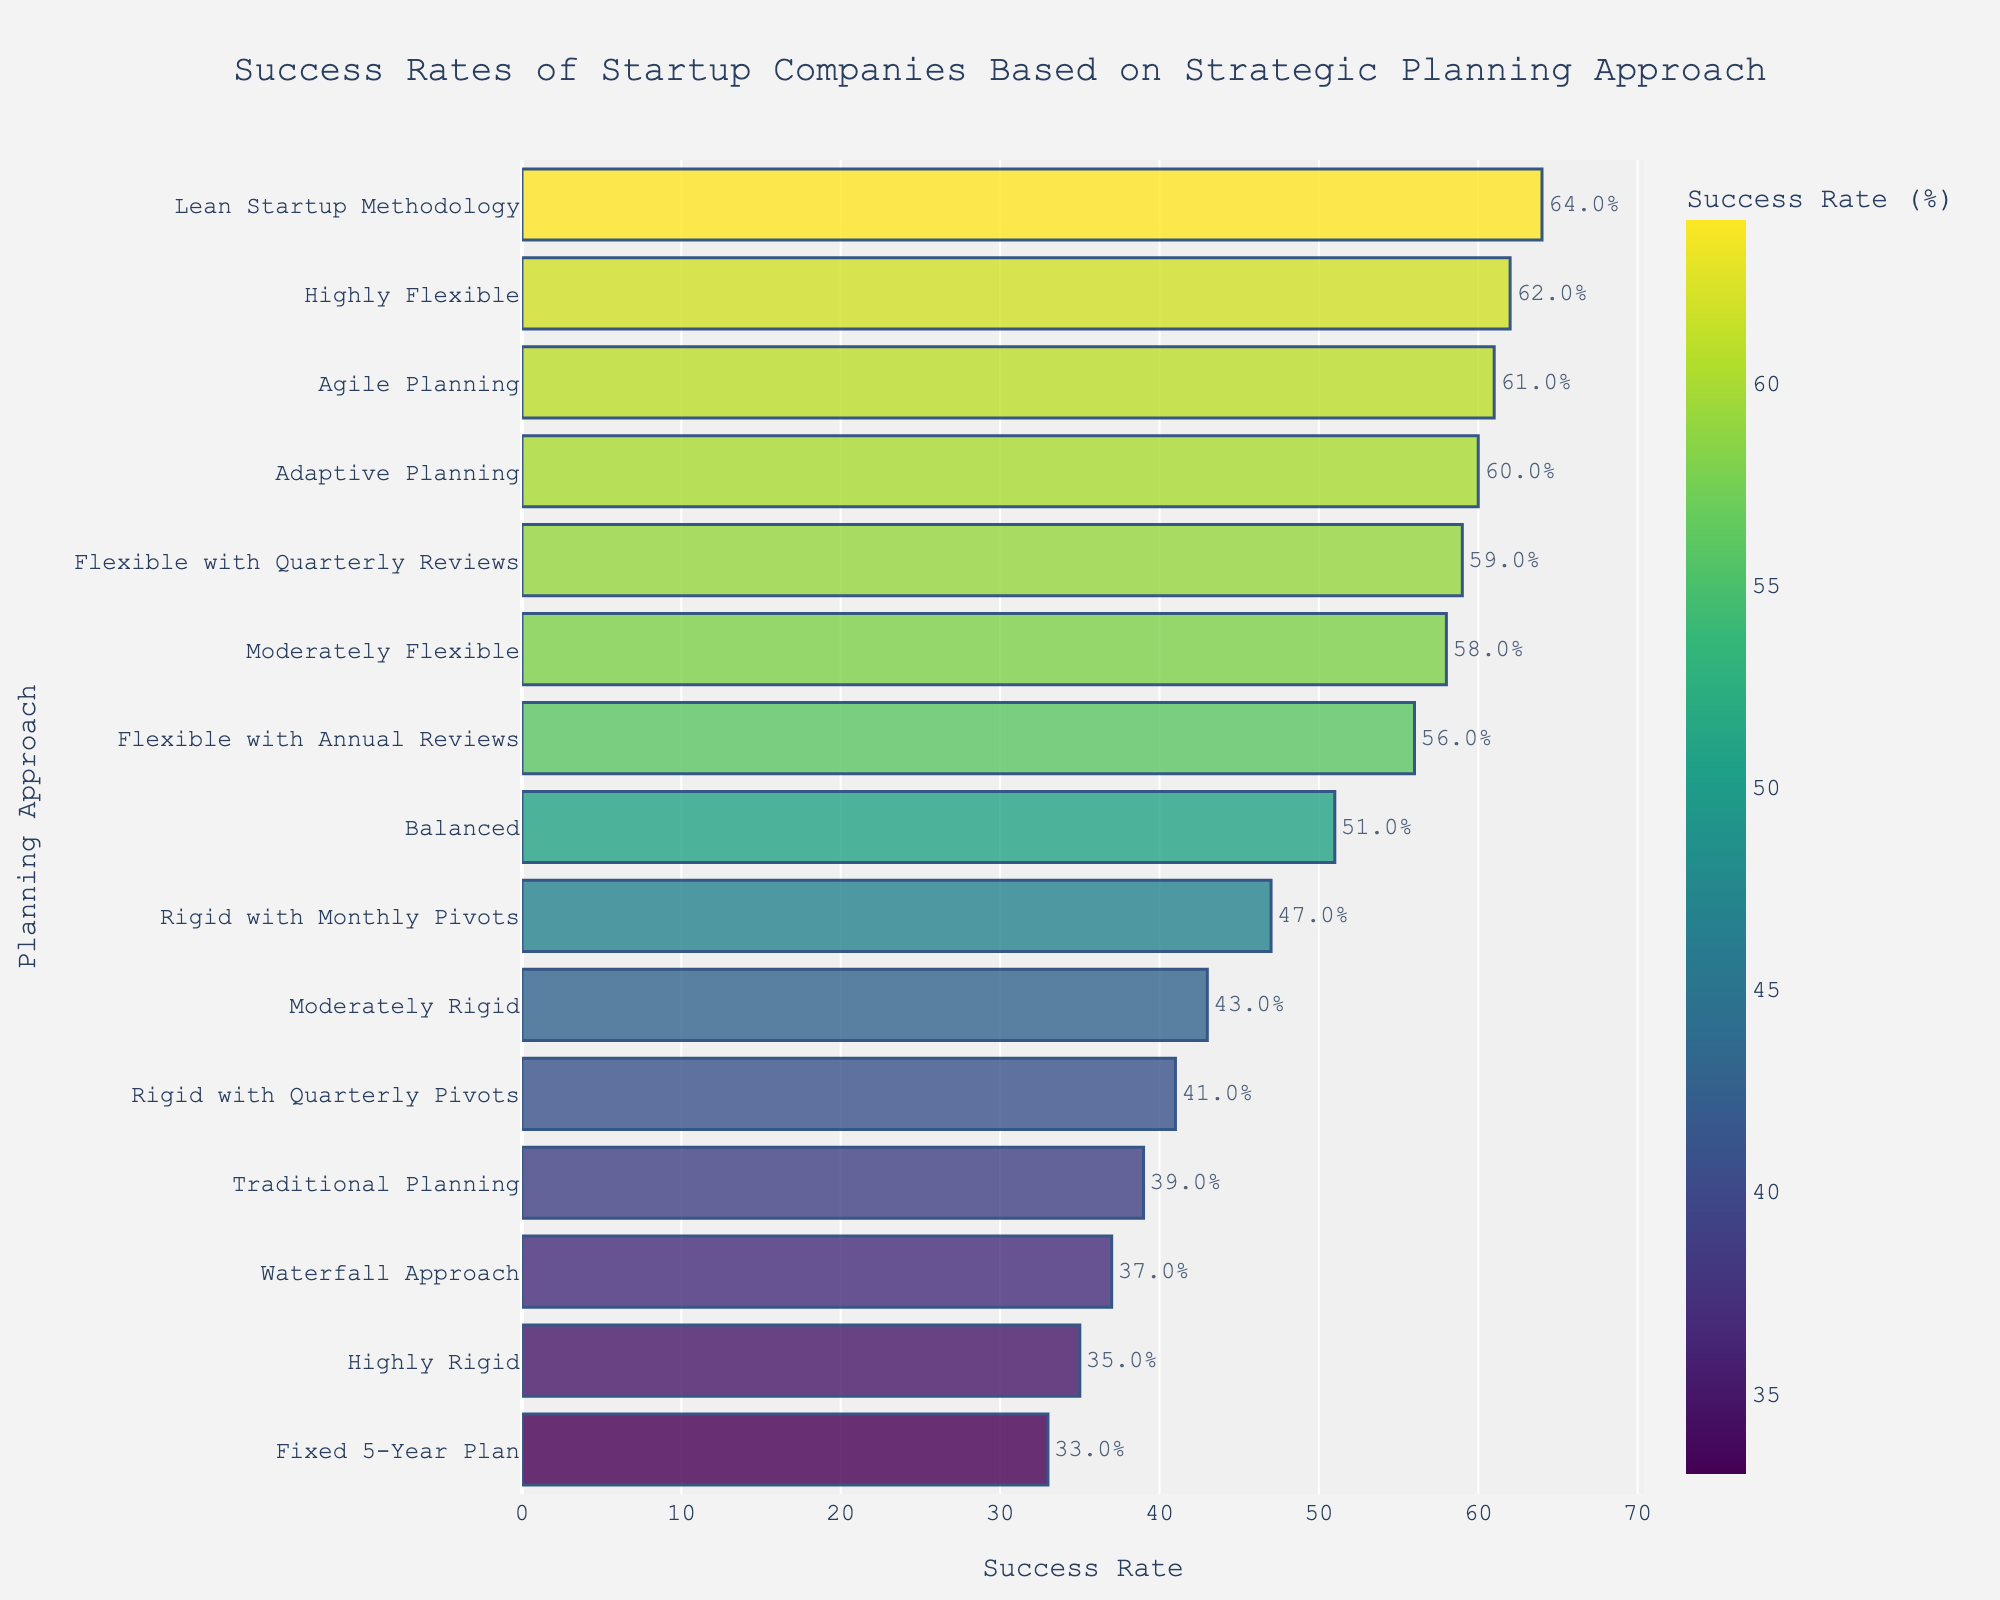What is the strategic planning approach with the highest success rate among startups? The bar chart shows different approaches to strategic planning with varying success rates. Identify the bar representing the highest success rate. This is the 'Lean Startup Methodology' approach, which has a success rate of 64%.
Answer: Lean Startup Methodology How many planning approaches have a success rate above 50%? Scan the success rate values shown next to each bar and count how many are above 50%. The approaches are Highly Flexible, Moderately Flexible, Balanced, Flexible with Quarterly Reviews, Flexible with Annual Reviews, Adaptive Planning, Lean Startup Methodology, and Agile Planning, making a total of 8 approaches.
Answer: 8 Which approach is more successful: Traditional Planning or Adaptive Planning? Compare the success rates of Traditional Planning (39%) and Adaptive Planning (60%) as shown on the bars in the chart. Adaptive Planning has a higher success rate.
Answer: Adaptive Planning What is the average success rate of the rigid planning approaches (Highly Rigid, Moderately Rigid, Rigid with Monthly Pivots, Rigid with Quarterly Pivots, Traditional Planning, Fixed 5-Year Plan)? Add the success rates of the rigid planning approaches (35, 43, 47, 41, 39, 33) and divide by the number of approaches (6). The sum is 238, and the average is 238/6 = 39.67%.
Answer: 39.67% Which has a higher success rate: Highly Flexible or Moderately Flexible planning? By how much? Identify the success rates of Highly Flexible (62%) and Moderately Flexible (58%) from the chart. Subtract the success rate of Moderately Flexible from Highly Flexible (62% - 58% = 4%).
Answer: Highly Flexible by 4% Which two approaches have the closest success rates, and what are those rates? Check the bars with success rates closest to each other. The closest are Rigid with Monthly Pivots (47%) and Balanced (51%), and Flexible with Annual Reviews (56%) and Moderately Flexible (58%). Choose any one pair if needed.
Answer: Flexible with Annual Reviews (56%) and Moderately Flexible (58%) How does the success rate of the Agile Planning approach compare to the Waterfall Approach? Compare the success rates listed for Agile Planning (61%) and Waterfall Approach (37%). Agile Planning has a higher success rate than the Waterfall Approach by 24 percentage points.
Answer: Agile Planning is 24% higher What proportion of planning approaches have a success rate below 50%? Determine the number of approaches with a success rate below 50% by viewing the values on the bars. There are 6 such approaches (Moderately Rigid, Highly Rigid, Rigid with Quarterly Pivots, Traditional Planning, Waterfall Approach, Fixed 5-Year Plan). There are 15 approaches in total, so the proportion is 6/15.
Answer: 0.4 or 40% What is the second most successful planning approach? Identify the second highest bar after the highest (Lean Startup Methodology). The second highest is Highly Flexible with a success rate of 62%.
Answer: Highly Flexible Which approach shows a success rate closest to 50% and what is the exact rate? Locate the bar whose label is nearest to 50%. The 'Balanced' approach is closest with a success rate of 51%.
Answer: Balanced with 51% 